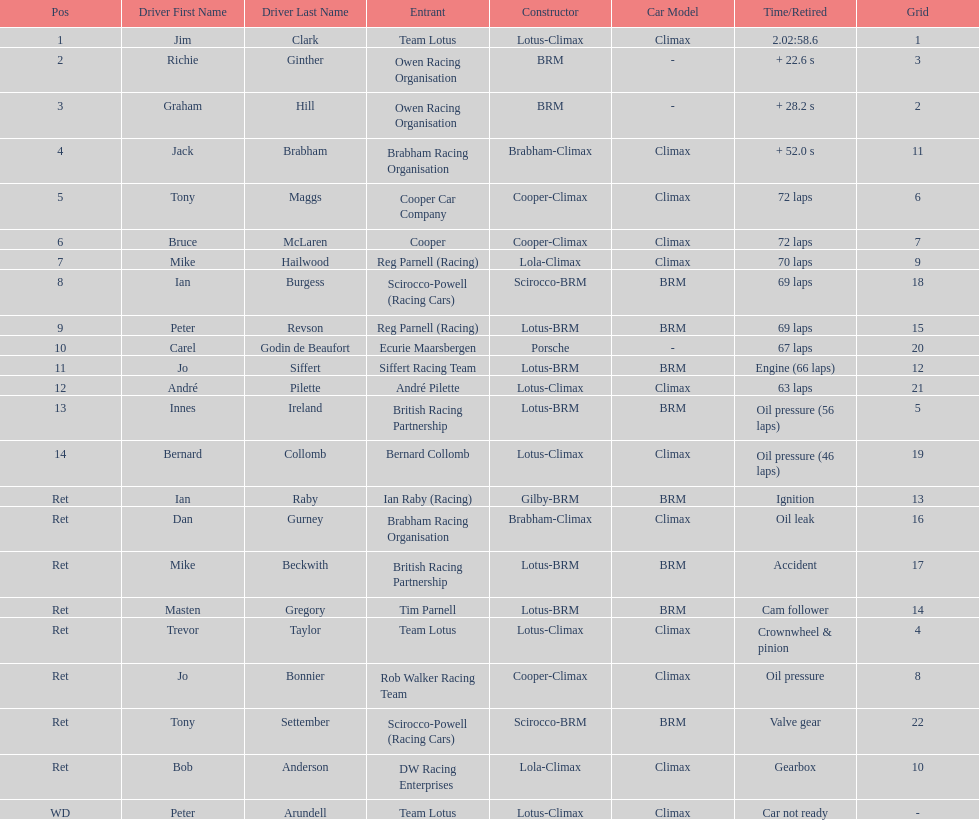Who came in earlier, tony maggs or jo siffert? Tony Maggs. 